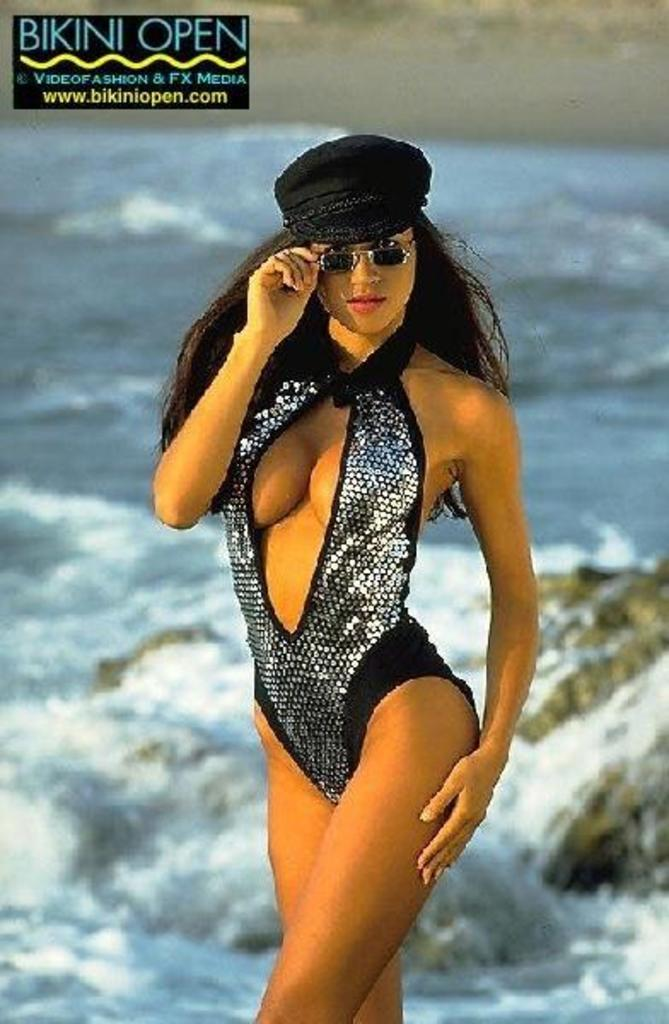Where was the image taken? The image is taken outdoors. What can be seen in the background of the image? There is a sea with waves in the background. What is located on the right side of the image? There is a rock on the right side of the image. Who is the main subject in the image? There is a woman in the middle of the image. What type of wilderness can be seen in the image? There is no wilderness present in the image; it features a woman standing near a rock with a sea in the background. Is the image taken during winter? The image does not provide any information about the season, so it cannot be determined if it was taken during winter. 